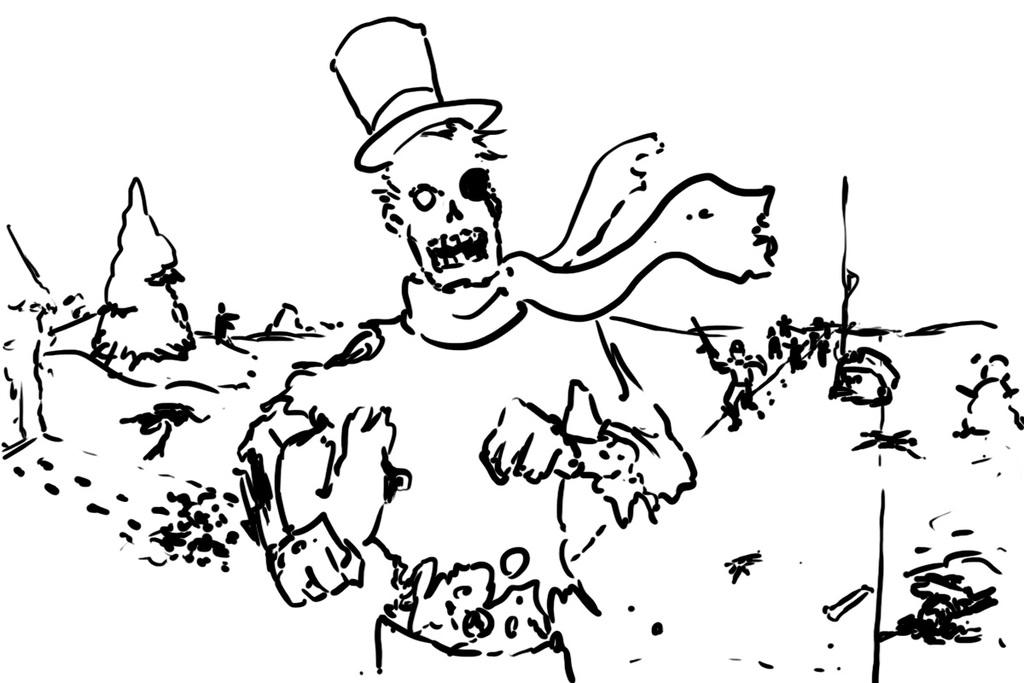What types of subjects are depicted in the sketch? The sketch contains people and a tree. Can you describe the setting or environment in the sketch? The presence of people and a tree suggests a natural or outdoor setting. What type of animal can be seen interacting with the tree in the sketch? There is no animal present in the sketch; it only contains people and a tree. What kind of machine is depicted in the sketch? There is no machine present in the sketch; it only contains people and a tree. 